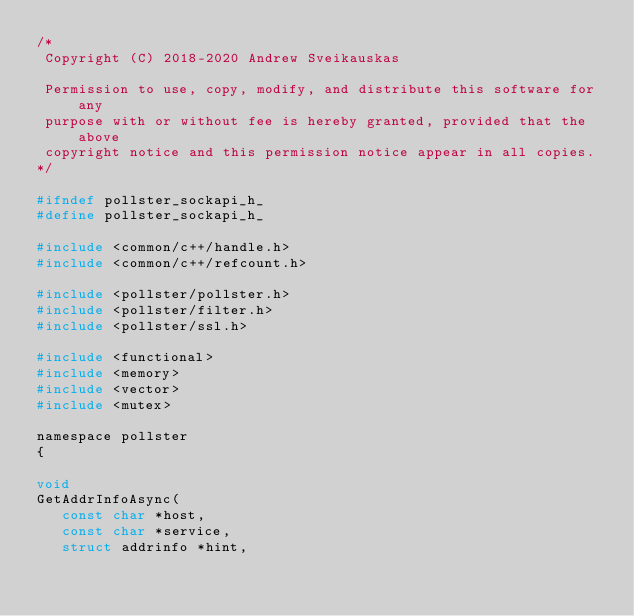Convert code to text. <code><loc_0><loc_0><loc_500><loc_500><_C_>/*
 Copyright (C) 2018-2020 Andrew Sveikauskas

 Permission to use, copy, modify, and distribute this software for any
 purpose with or without fee is hereby granted, provided that the above
 copyright notice and this permission notice appear in all copies.
*/

#ifndef pollster_sockapi_h_
#define pollster_sockapi_h_

#include <common/c++/handle.h>
#include <common/c++/refcount.h>

#include <pollster/pollster.h>
#include <pollster/filter.h>
#include <pollster/ssl.h>

#include <functional>
#include <memory>
#include <vector>
#include <mutex>

namespace pollster
{

void
GetAddrInfoAsync(
   const char *host,
   const char *service,
   struct addrinfo *hint,</code> 